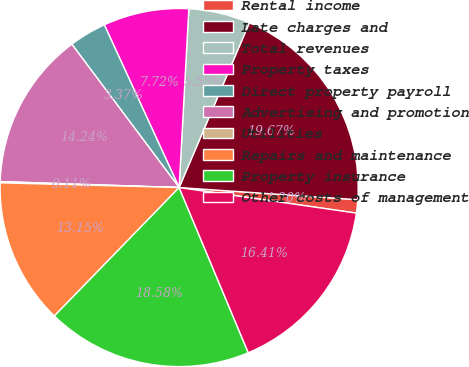Convert chart. <chart><loc_0><loc_0><loc_500><loc_500><pie_chart><fcel>Rental income<fcel>Late charges and<fcel>Total revenues<fcel>Property taxes<fcel>Direct property payroll<fcel>Advertising and promotion<fcel>Utilities<fcel>Repairs and maintenance<fcel>Property insurance<fcel>Other costs of management<nl><fcel>1.2%<fcel>19.67%<fcel>5.55%<fcel>7.72%<fcel>3.37%<fcel>14.24%<fcel>0.11%<fcel>13.15%<fcel>18.58%<fcel>16.41%<nl></chart> 